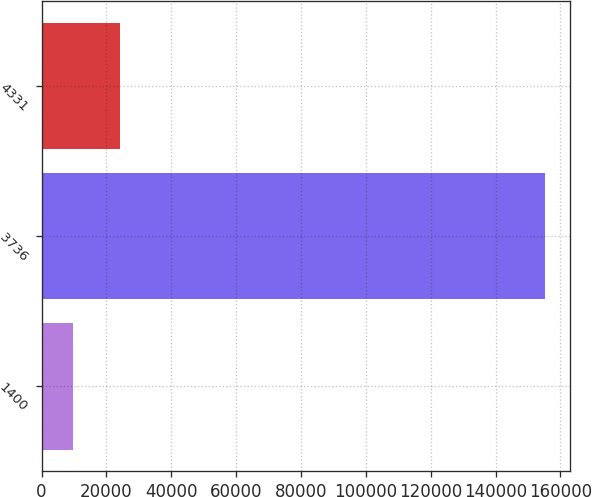Convert chart. <chart><loc_0><loc_0><loc_500><loc_500><bar_chart><fcel>1400<fcel>3736<fcel>4331<nl><fcel>9688<fcel>155230<fcel>24242.2<nl></chart> 